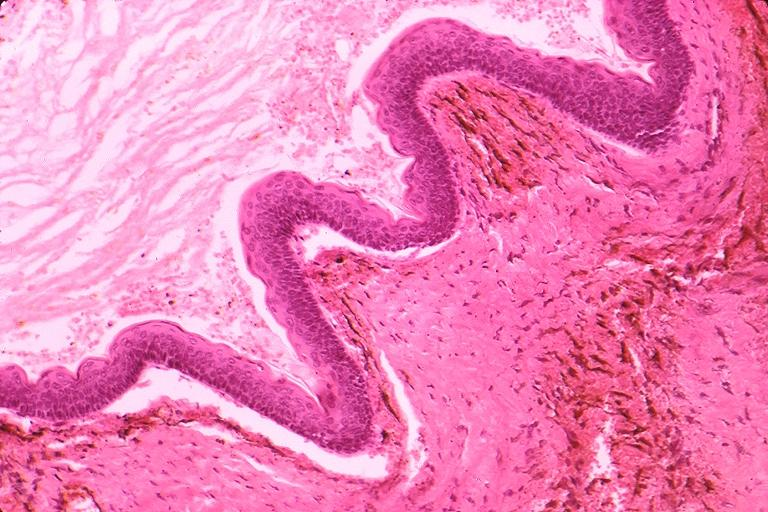what is present?
Answer the question using a single word or phrase. Oral 